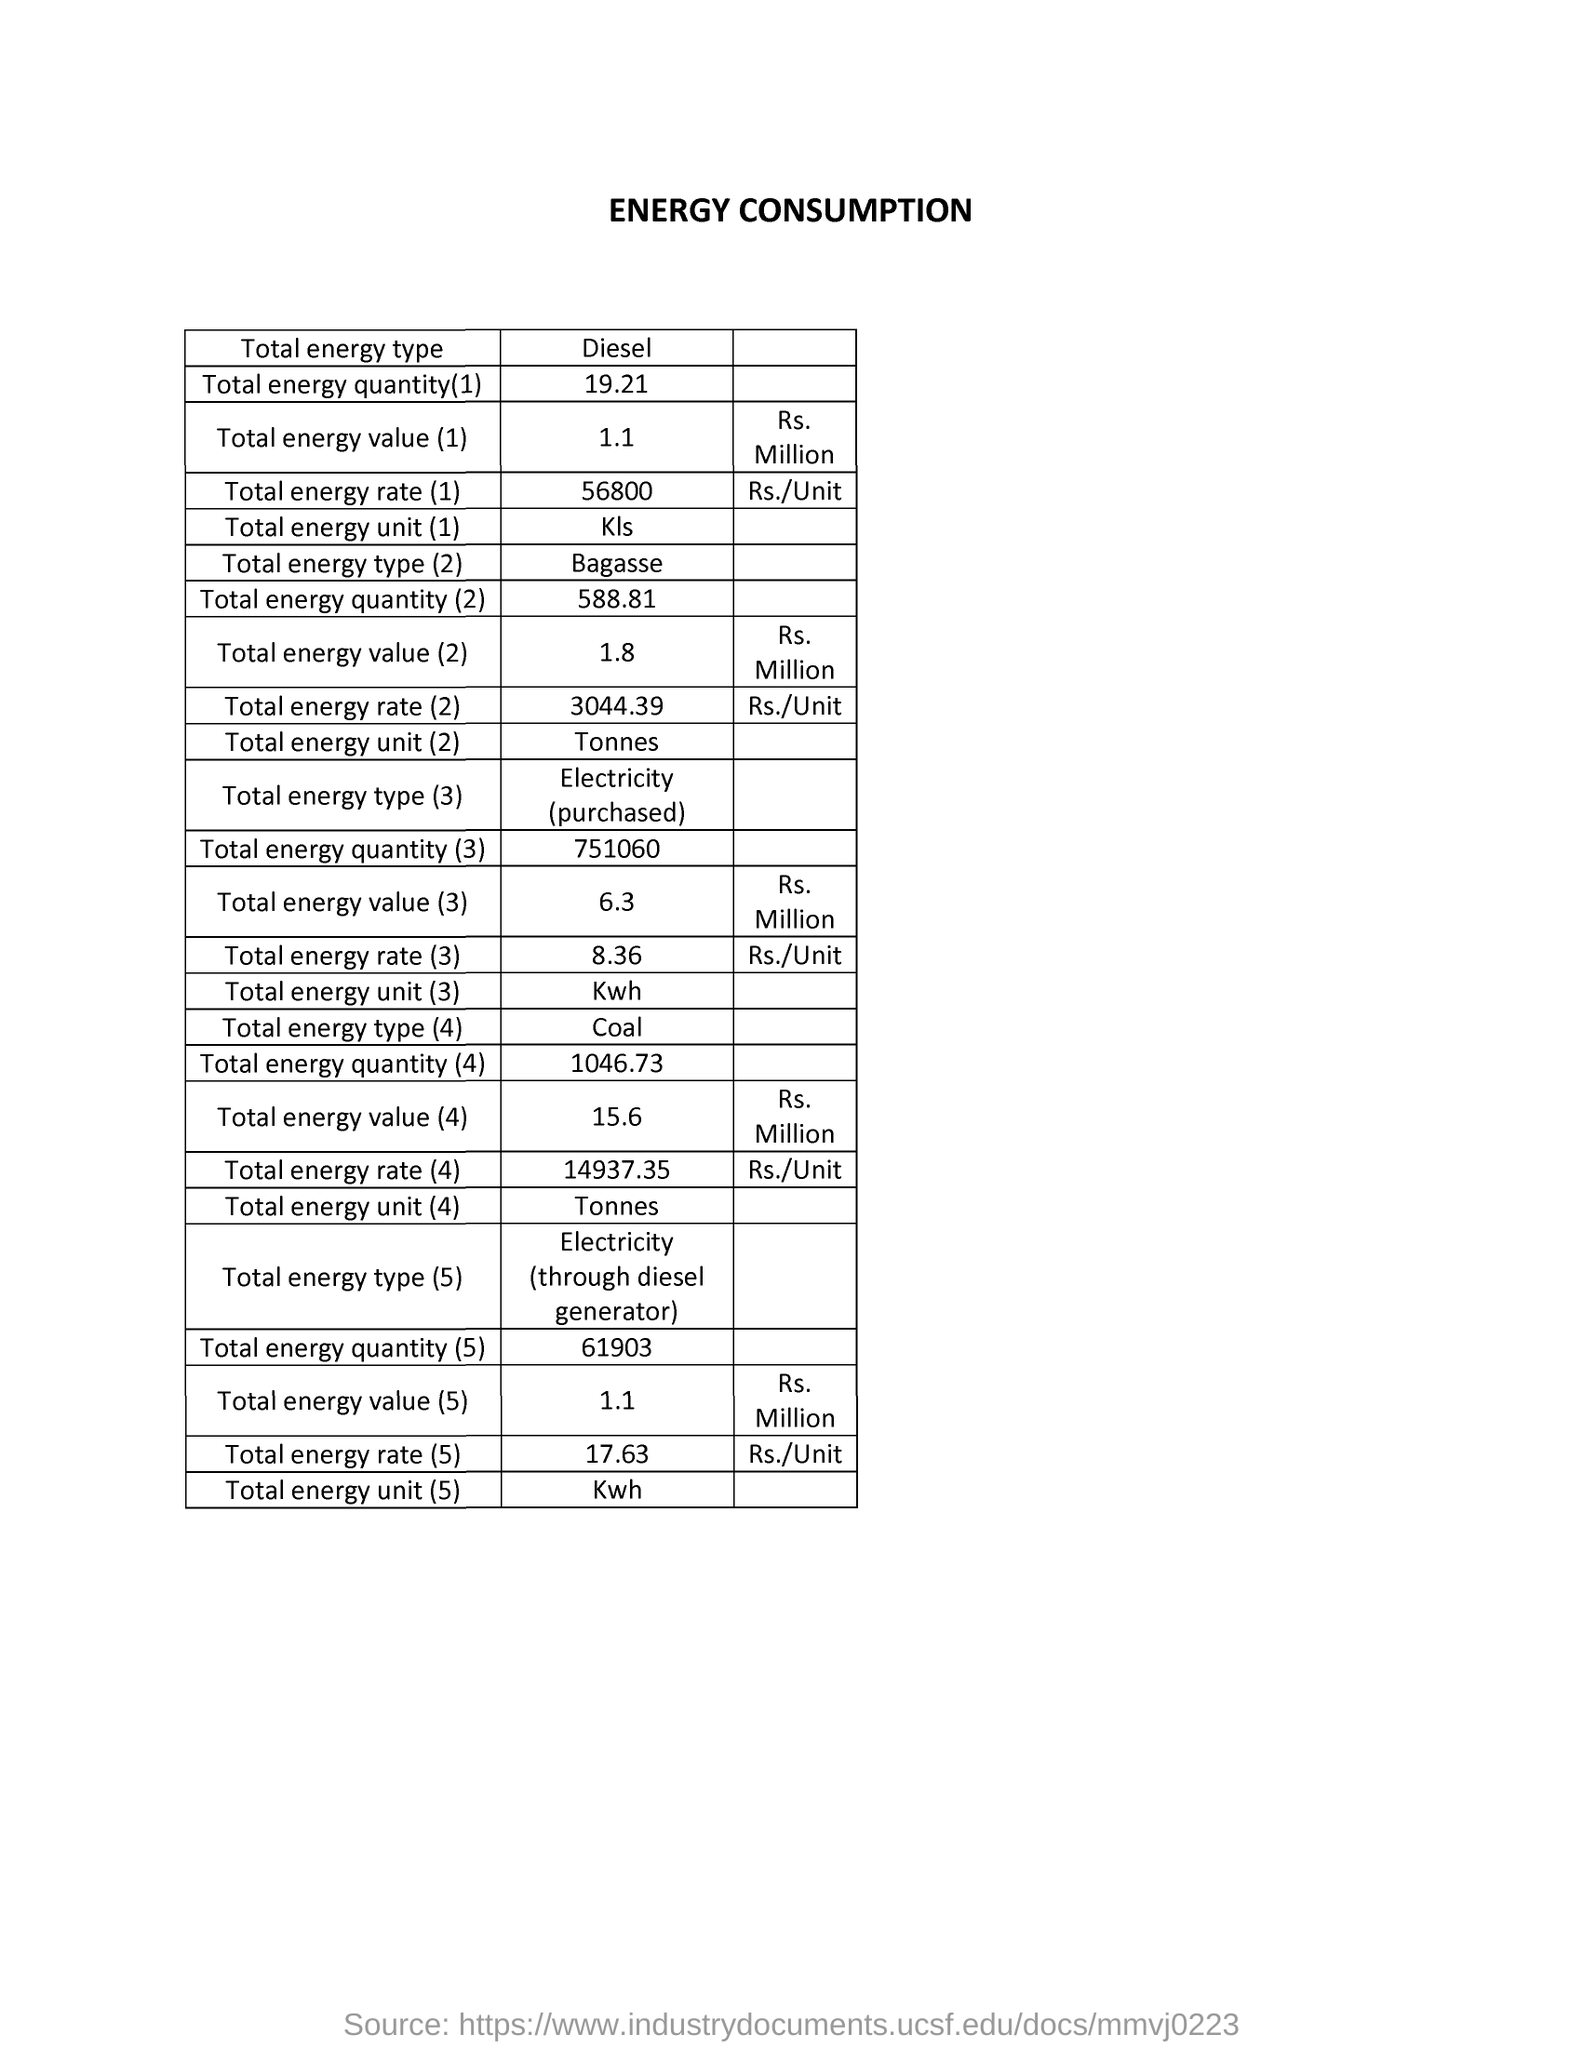What is the title of the document?
Provide a short and direct response. Energy Consumption. What is the total energy value for energy type diesel?
Offer a very short reply. 1.1 Rs. Million. What is the total energy rate for energy type diesel?
Give a very brief answer. 56800. The total energy value is high for which energy type?
Provide a succinct answer. Coal. What is the total energy rate for energy type coal?
Offer a very short reply. 14937.35. What is the total energy unit of Bagasse?
Offer a terse response. Tonnes. 